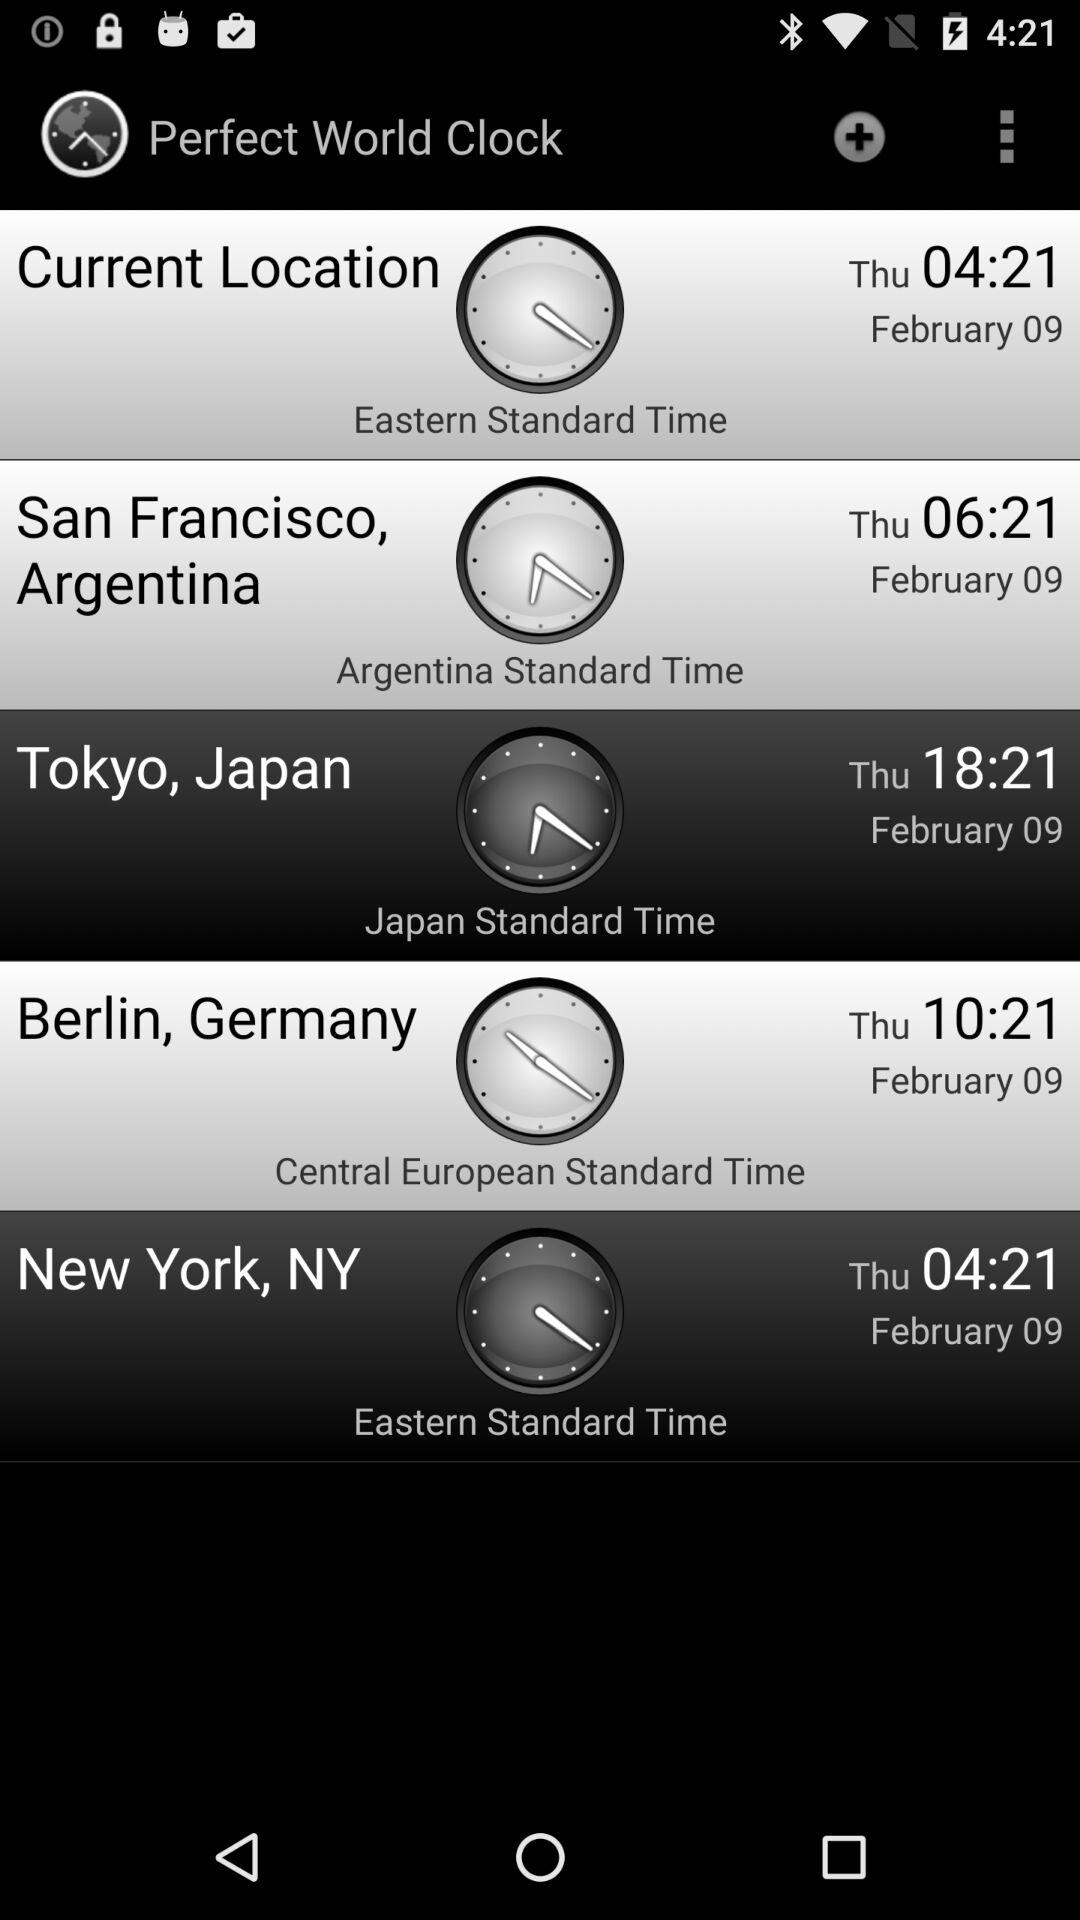What is the current location?
When the provided information is insufficient, respond with <no answer>. <no answer> 